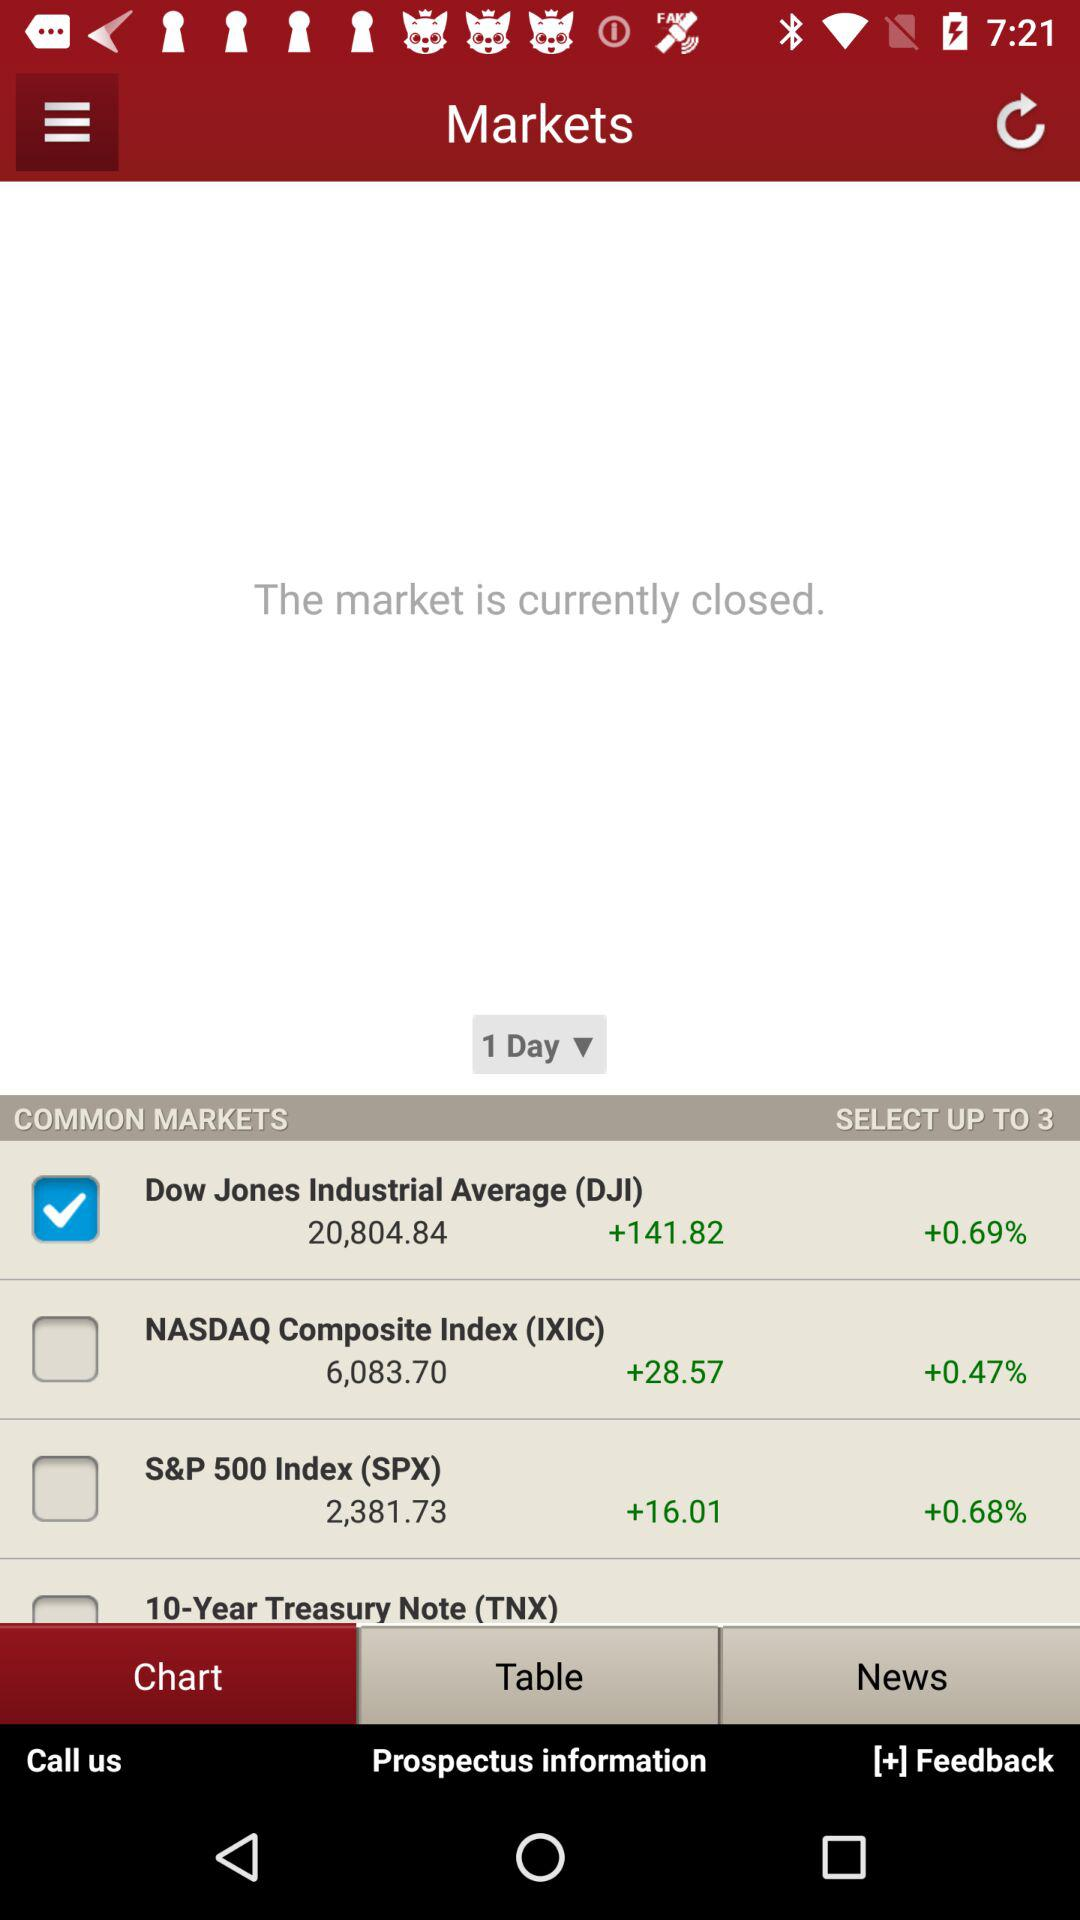Is the market currently open? The market is currently closed. 